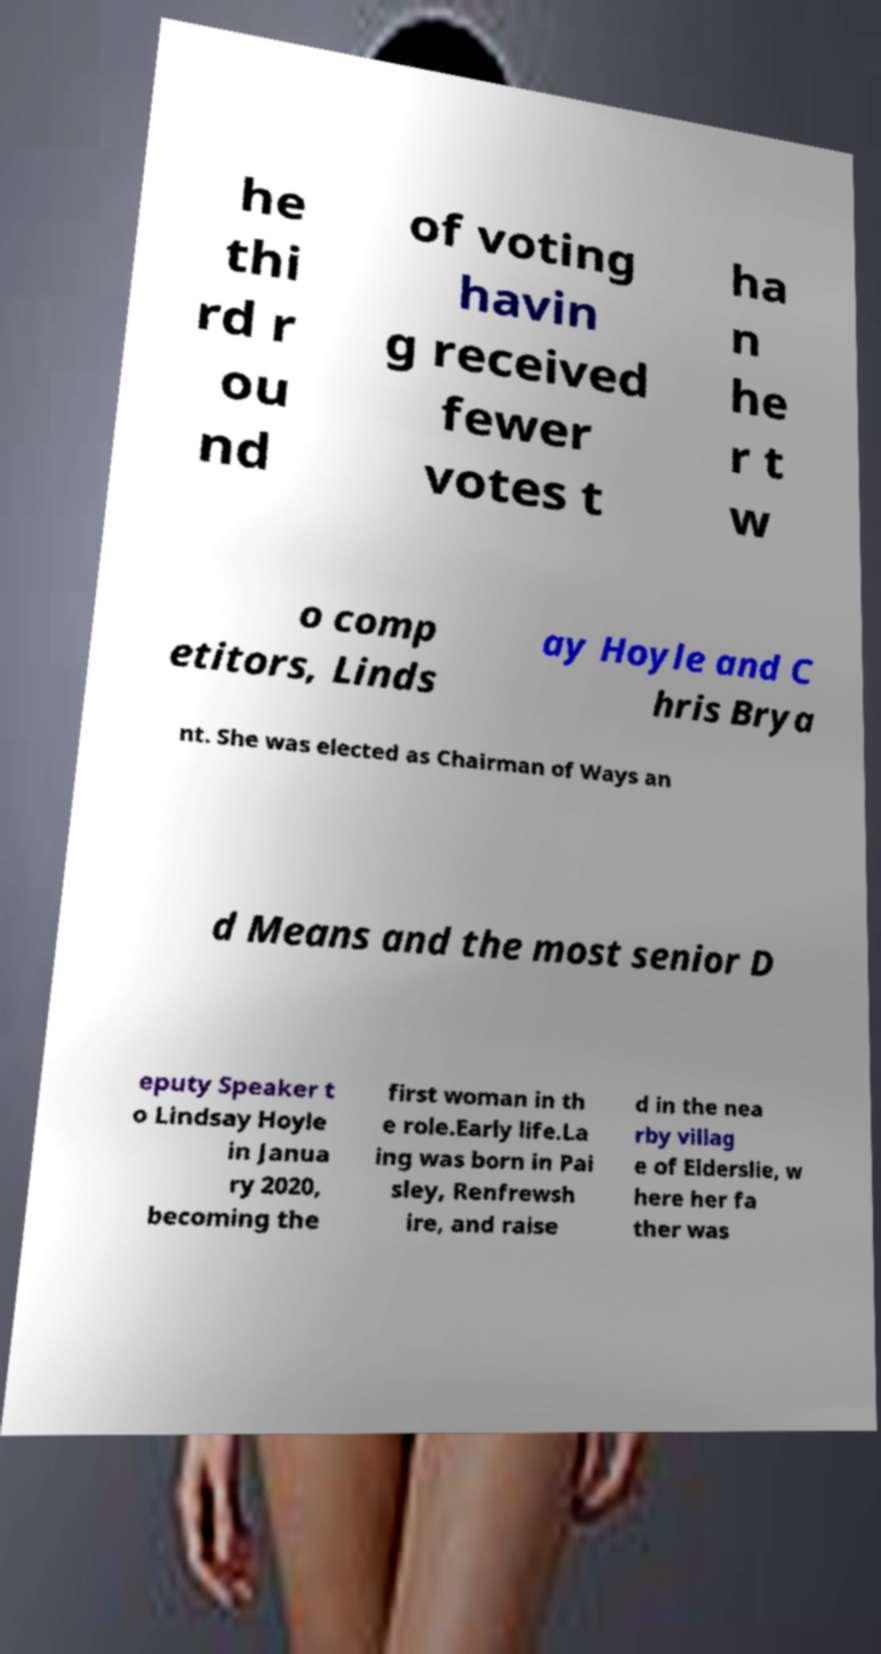Please read and relay the text visible in this image. What does it say? he thi rd r ou nd of voting havin g received fewer votes t ha n he r t w o comp etitors, Linds ay Hoyle and C hris Brya nt. She was elected as Chairman of Ways an d Means and the most senior D eputy Speaker t o Lindsay Hoyle in Janua ry 2020, becoming the first woman in th e role.Early life.La ing was born in Pai sley, Renfrewsh ire, and raise d in the nea rby villag e of Elderslie, w here her fa ther was 